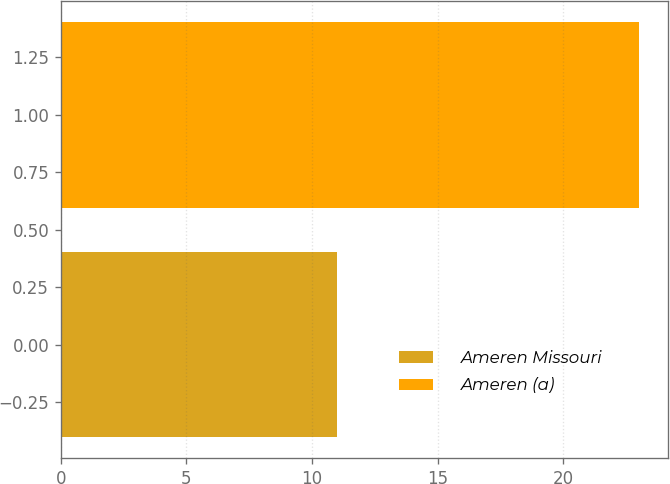Convert chart. <chart><loc_0><loc_0><loc_500><loc_500><bar_chart><fcel>Ameren Missouri<fcel>Ameren (a)<nl><fcel>11<fcel>23<nl></chart> 